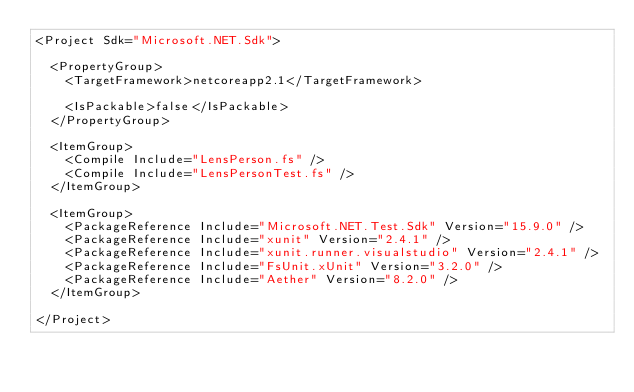Convert code to text. <code><loc_0><loc_0><loc_500><loc_500><_XML_><Project Sdk="Microsoft.NET.Sdk">

  <PropertyGroup>
    <TargetFramework>netcoreapp2.1</TargetFramework>

    <IsPackable>false</IsPackable>
  </PropertyGroup>

  <ItemGroup>
    <Compile Include="LensPerson.fs" />
    <Compile Include="LensPersonTest.fs" />
  </ItemGroup>

  <ItemGroup>
    <PackageReference Include="Microsoft.NET.Test.Sdk" Version="15.9.0" />
    <PackageReference Include="xunit" Version="2.4.1" />
    <PackageReference Include="xunit.runner.visualstudio" Version="2.4.1" />
    <PackageReference Include="FsUnit.xUnit" Version="3.2.0" />
    <PackageReference Include="Aether" Version="8.2.0" />
  </ItemGroup>

</Project>
</code> 